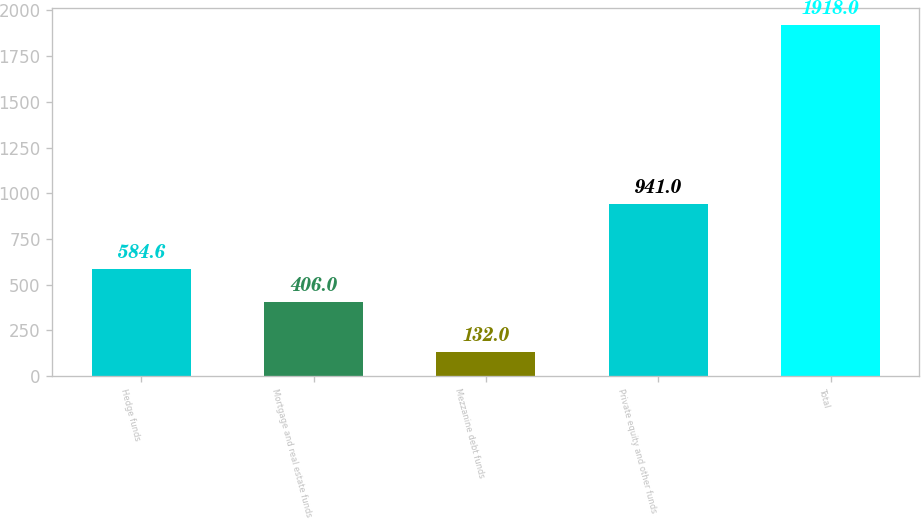<chart> <loc_0><loc_0><loc_500><loc_500><bar_chart><fcel>Hedge funds<fcel>Mortgage and real estate funds<fcel>Mezzanine debt funds<fcel>Private equity and other funds<fcel>Total<nl><fcel>584.6<fcel>406<fcel>132<fcel>941<fcel>1918<nl></chart> 